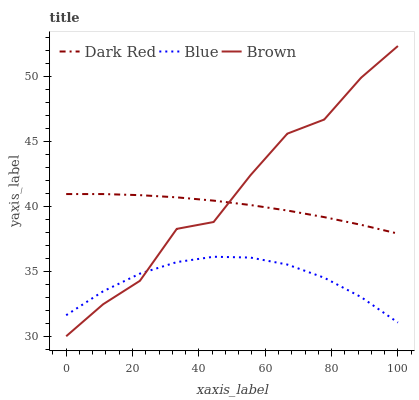Does Blue have the minimum area under the curve?
Answer yes or no. Yes. Does Brown have the maximum area under the curve?
Answer yes or no. Yes. Does Dark Red have the minimum area under the curve?
Answer yes or no. No. Does Dark Red have the maximum area under the curve?
Answer yes or no. No. Is Dark Red the smoothest?
Answer yes or no. Yes. Is Brown the roughest?
Answer yes or no. Yes. Is Brown the smoothest?
Answer yes or no. No. Is Dark Red the roughest?
Answer yes or no. No. Does Brown have the lowest value?
Answer yes or no. Yes. Does Dark Red have the lowest value?
Answer yes or no. No. Does Brown have the highest value?
Answer yes or no. Yes. Does Dark Red have the highest value?
Answer yes or no. No. Is Blue less than Dark Red?
Answer yes or no. Yes. Is Dark Red greater than Blue?
Answer yes or no. Yes. Does Brown intersect Blue?
Answer yes or no. Yes. Is Brown less than Blue?
Answer yes or no. No. Is Brown greater than Blue?
Answer yes or no. No. Does Blue intersect Dark Red?
Answer yes or no. No. 